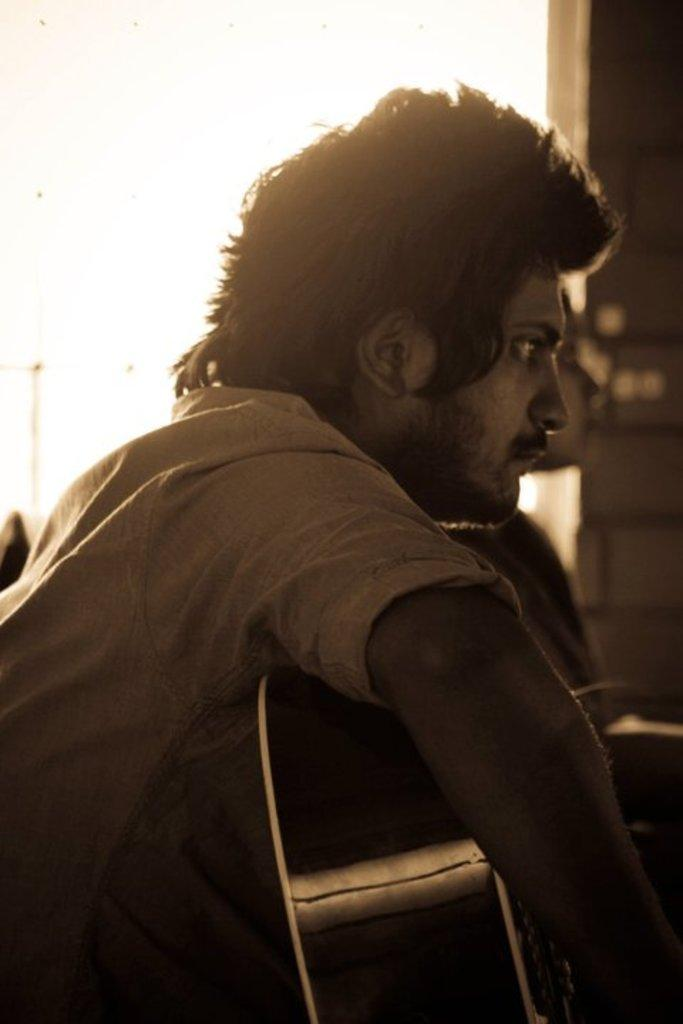What is the man in the image doing? The man is sitting in the image. What object is the man holding in his hand? The man is holding a guitar in his hand. Can you describe the person sitting behind the man? There is a person sitting behind the man, but no specific details about the person are provided. What theory is the man discussing with the person sitting behind him in the image? There is no indication in the image that the man is discussing any theory with the person sitting behind him. 